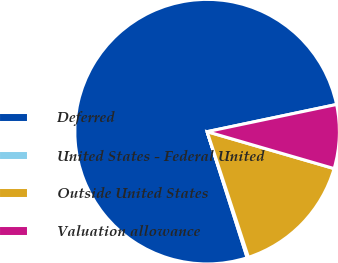Convert chart. <chart><loc_0><loc_0><loc_500><loc_500><pie_chart><fcel>Deferred<fcel>United States - Federal United<fcel>Outside United States<fcel>Valuation allowance<nl><fcel>76.6%<fcel>0.16%<fcel>15.44%<fcel>7.8%<nl></chart> 